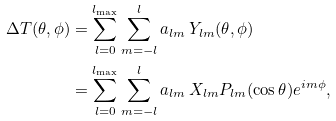<formula> <loc_0><loc_0><loc_500><loc_500>\Delta T ( \theta , \phi ) & = \sum _ { l = 0 } ^ { l _ { \max } } \sum _ { m = - l } ^ { l } a _ { l m } \, Y _ { l m } ( \theta , \phi ) \\ & = \sum _ { l = 0 } ^ { l _ { \max } } \sum _ { m = - l } ^ { l } a _ { l m } \, X _ { l m } P _ { l m } ( \cos \theta ) e ^ { i m \phi } ,</formula> 